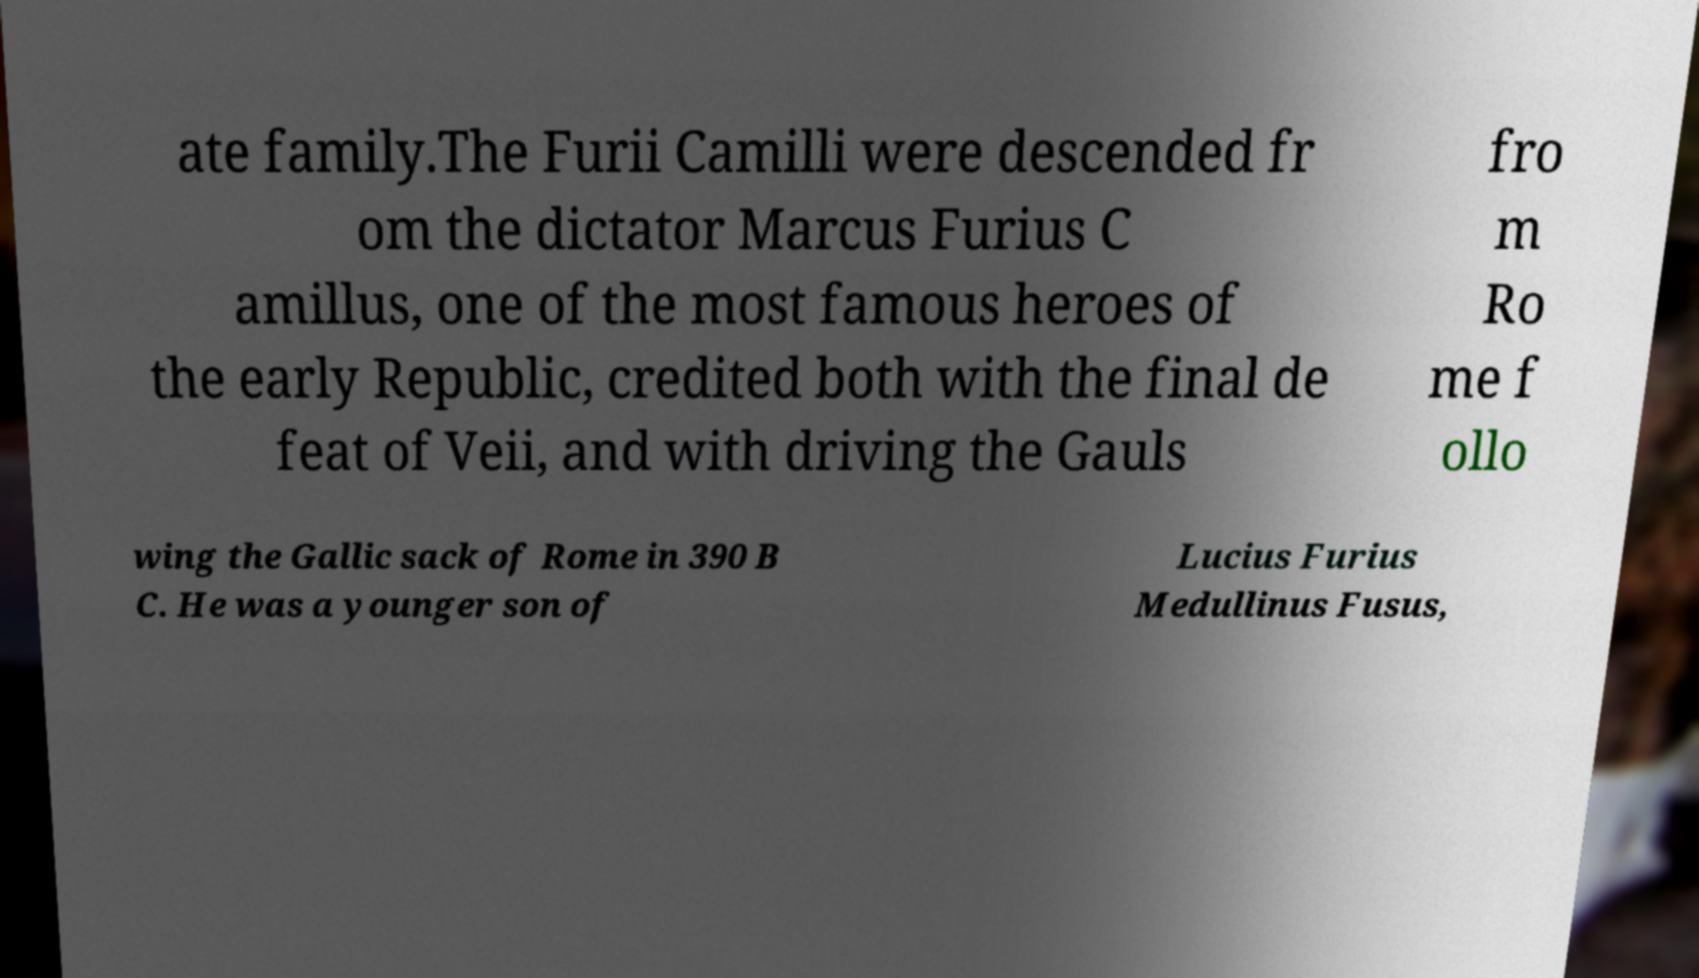Can you read and provide the text displayed in the image?This photo seems to have some interesting text. Can you extract and type it out for me? ate family.The Furii Camilli were descended fr om the dictator Marcus Furius C amillus, one of the most famous heroes of the early Republic, credited both with the final de feat of Veii, and with driving the Gauls fro m Ro me f ollo wing the Gallic sack of Rome in 390 B C. He was a younger son of Lucius Furius Medullinus Fusus, 